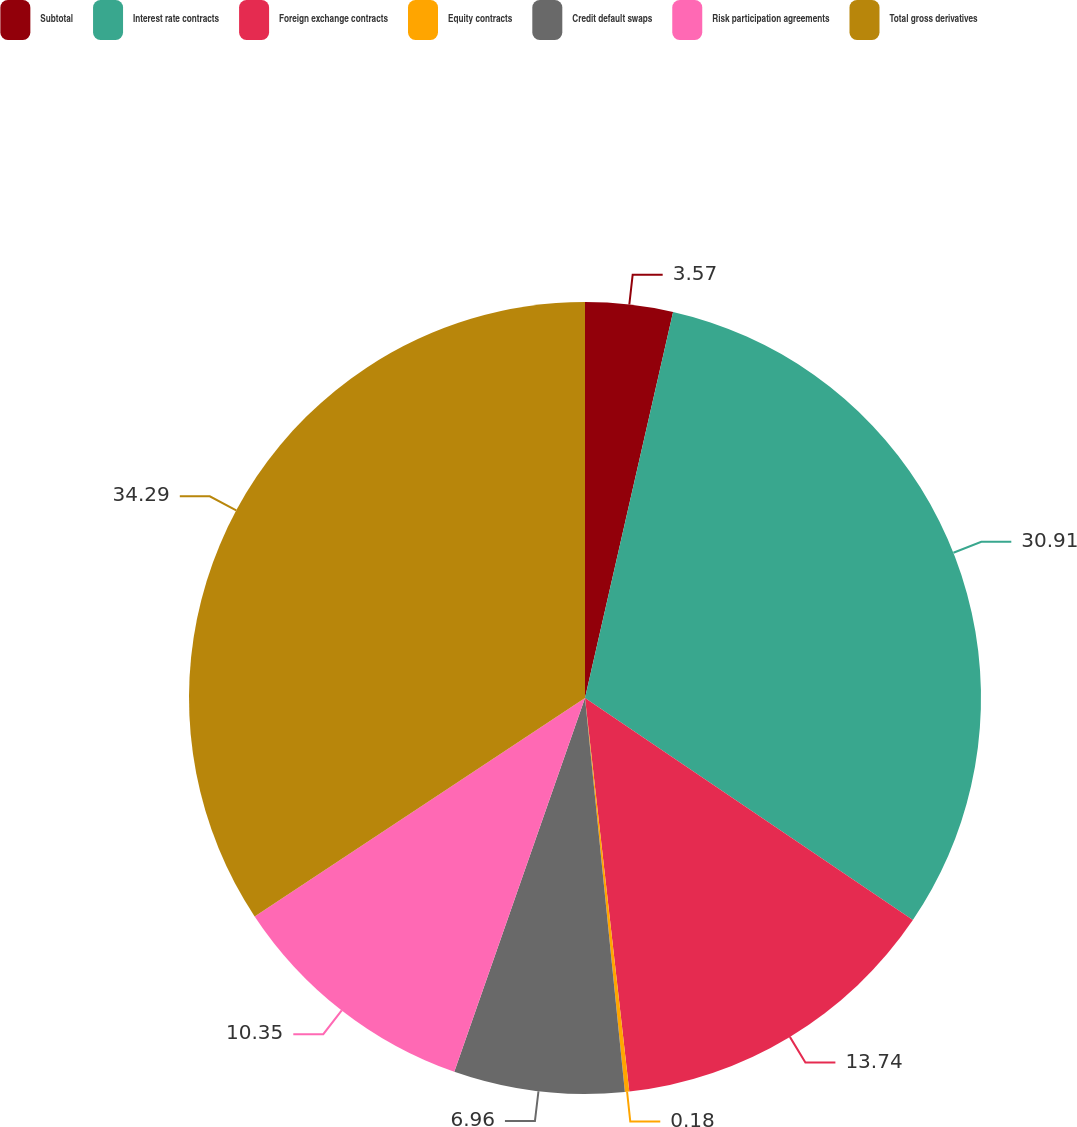Convert chart. <chart><loc_0><loc_0><loc_500><loc_500><pie_chart><fcel>Subtotal<fcel>Interest rate contracts<fcel>Foreign exchange contracts<fcel>Equity contracts<fcel>Credit default swaps<fcel>Risk participation agreements<fcel>Total gross derivatives<nl><fcel>3.57%<fcel>30.91%<fcel>13.74%<fcel>0.18%<fcel>6.96%<fcel>10.35%<fcel>34.3%<nl></chart> 